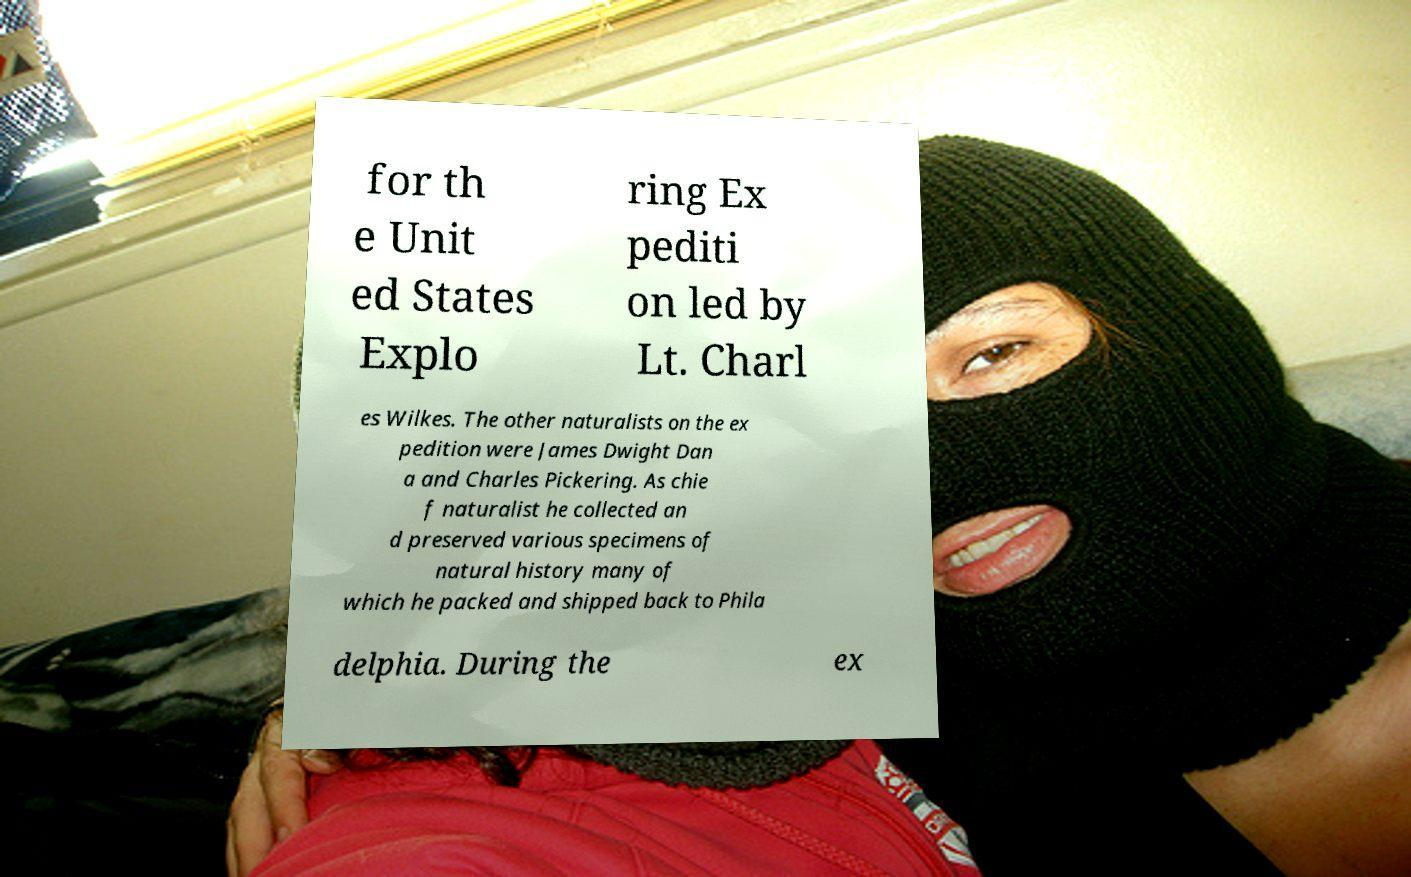Can you read and provide the text displayed in the image?This photo seems to have some interesting text. Can you extract and type it out for me? for th e Unit ed States Explo ring Ex pediti on led by Lt. Charl es Wilkes. The other naturalists on the ex pedition were James Dwight Dan a and Charles Pickering. As chie f naturalist he collected an d preserved various specimens of natural history many of which he packed and shipped back to Phila delphia. During the ex 